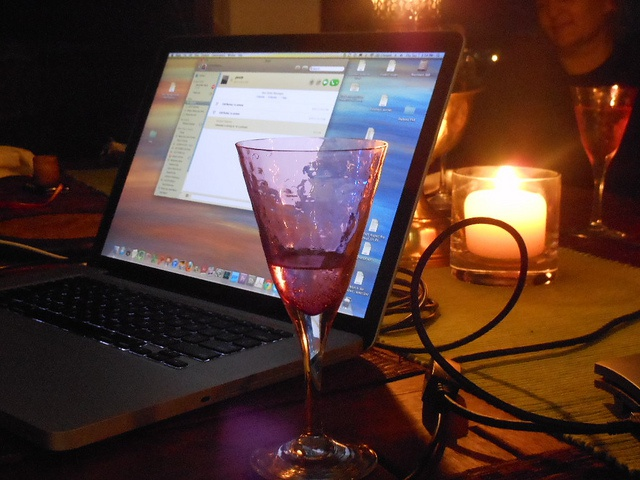Describe the objects in this image and their specific colors. I can see laptop in black, lavender, brown, and darkgray tones, wine glass in black, maroon, gray, and lavender tones, people in black, maroon, and brown tones, wine glass in black, maroon, and brown tones, and wine glass in black, maroon, brown, and orange tones in this image. 